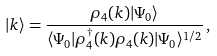<formula> <loc_0><loc_0><loc_500><loc_500>| { k } \rangle = \frac { \rho _ { 4 } ( { k } ) | \Psi _ { 0 } \rangle } { \langle \Psi _ { 0 } | \rho _ { 4 } ^ { \dagger } ( { k } ) \rho _ { 4 } ( { k } ) | \Psi _ { 0 } \rangle ^ { 1 / 2 } } \, ,</formula> 